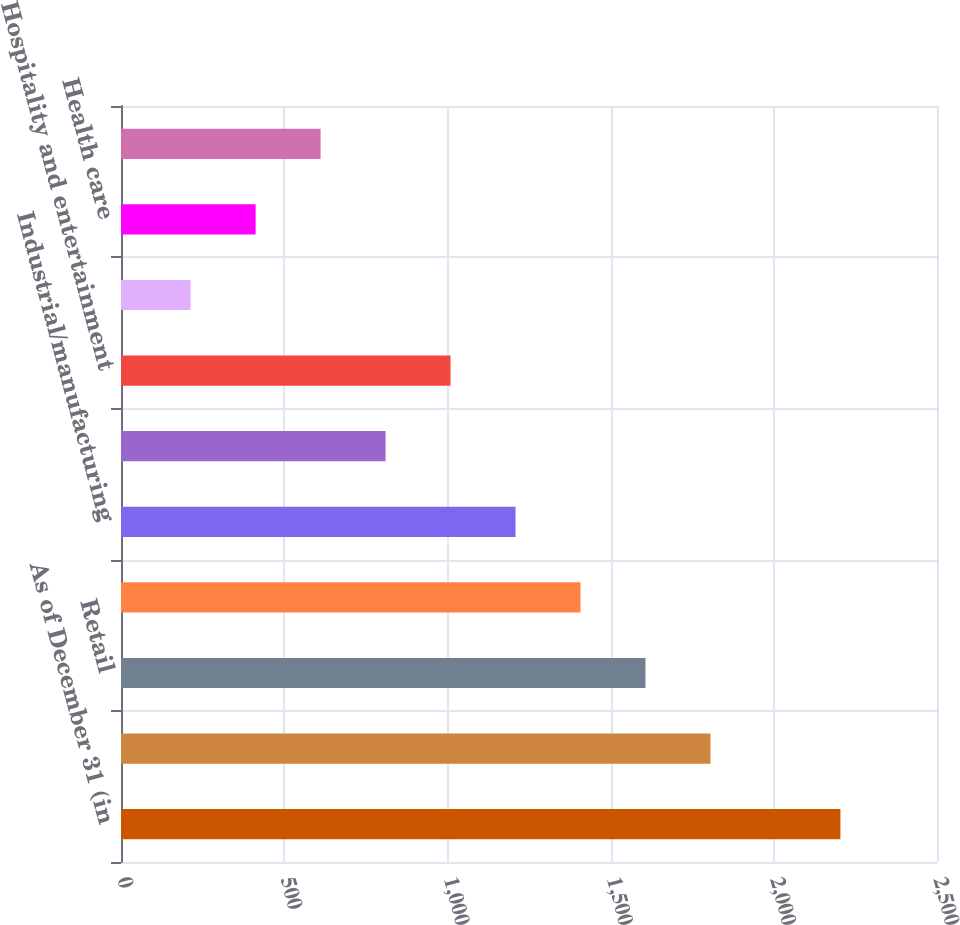Convert chart. <chart><loc_0><loc_0><loc_500><loc_500><bar_chart><fcel>As of December 31 (in<fcel>Residential<fcel>Retail<fcel>Office buildings<fcel>Industrial/manufacturing<fcel>Self storage/industrial<fcel>Hospitality and entertainment<fcel>Land<fcel>Health care<fcel>Special use<nl><fcel>2204.07<fcel>1805.93<fcel>1606.86<fcel>1407.79<fcel>1208.72<fcel>810.58<fcel>1009.65<fcel>213.37<fcel>412.44<fcel>611.51<nl></chart> 